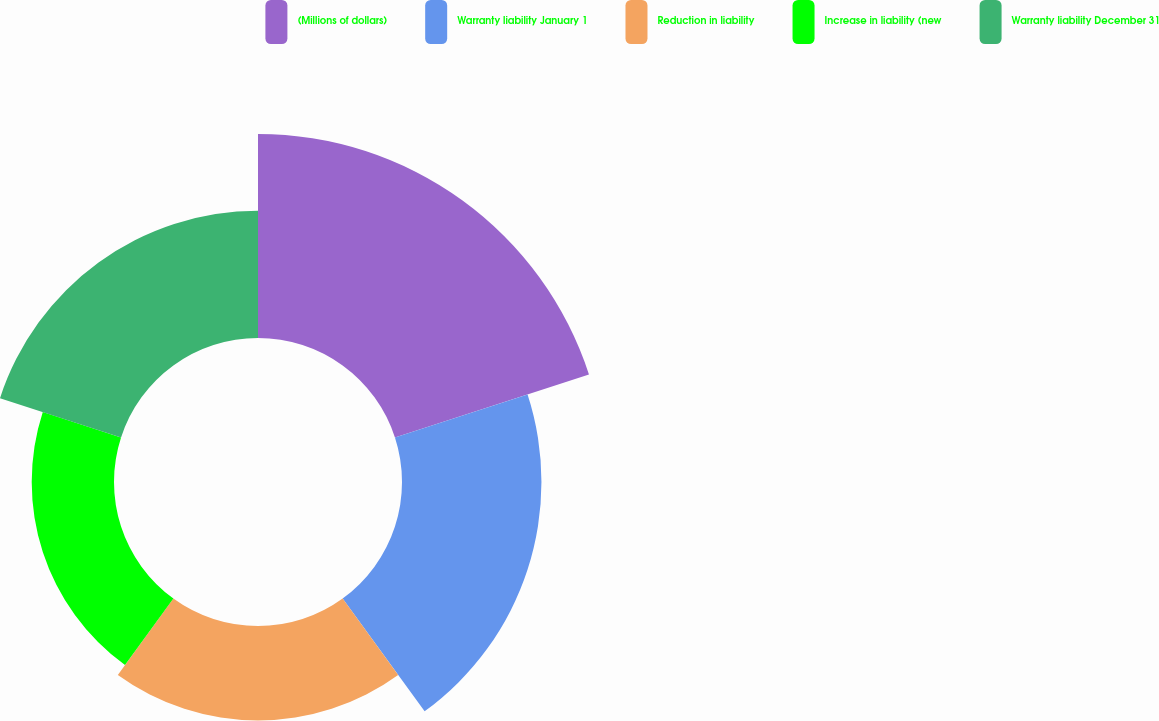Convert chart. <chart><loc_0><loc_0><loc_500><loc_500><pie_chart><fcel>(Millions of dollars)<fcel>Warranty liability January 1<fcel>Reduction in liability<fcel>Increase in liability (new<fcel>Warranty liability December 31<nl><fcel>31.51%<fcel>21.54%<fcel>14.59%<fcel>12.71%<fcel>19.66%<nl></chart> 